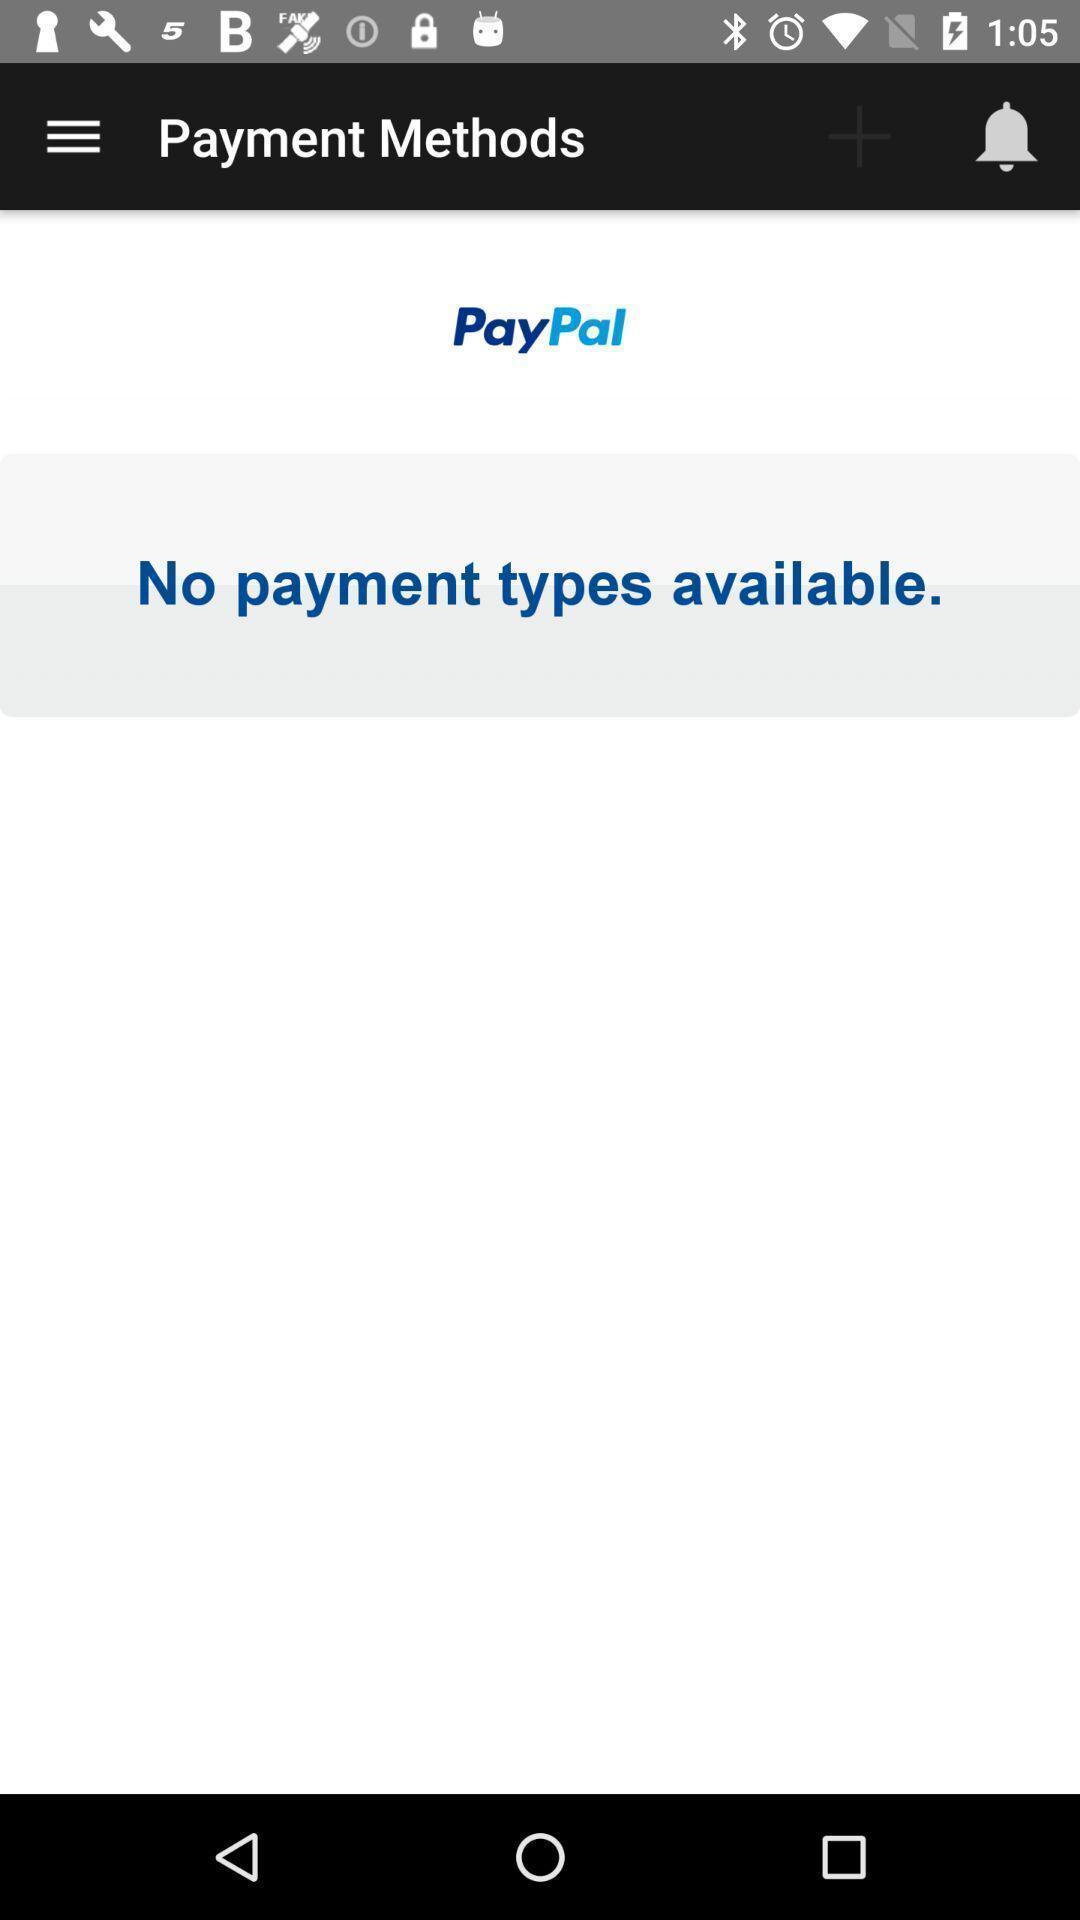Give me a summary of this screen capture. Screen shows payment methods page in financial app. 